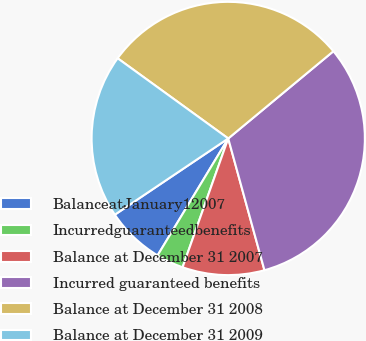Convert chart. <chart><loc_0><loc_0><loc_500><loc_500><pie_chart><fcel>BalanceatJanuary12007<fcel>Incurredguaranteedbenefits<fcel>Balance at December 31 2007<fcel>Incurred guaranteed benefits<fcel>Balance at December 31 2008<fcel>Balance at December 31 2009<nl><fcel>6.93%<fcel>3.23%<fcel>9.69%<fcel>31.75%<fcel>28.99%<fcel>19.4%<nl></chart> 